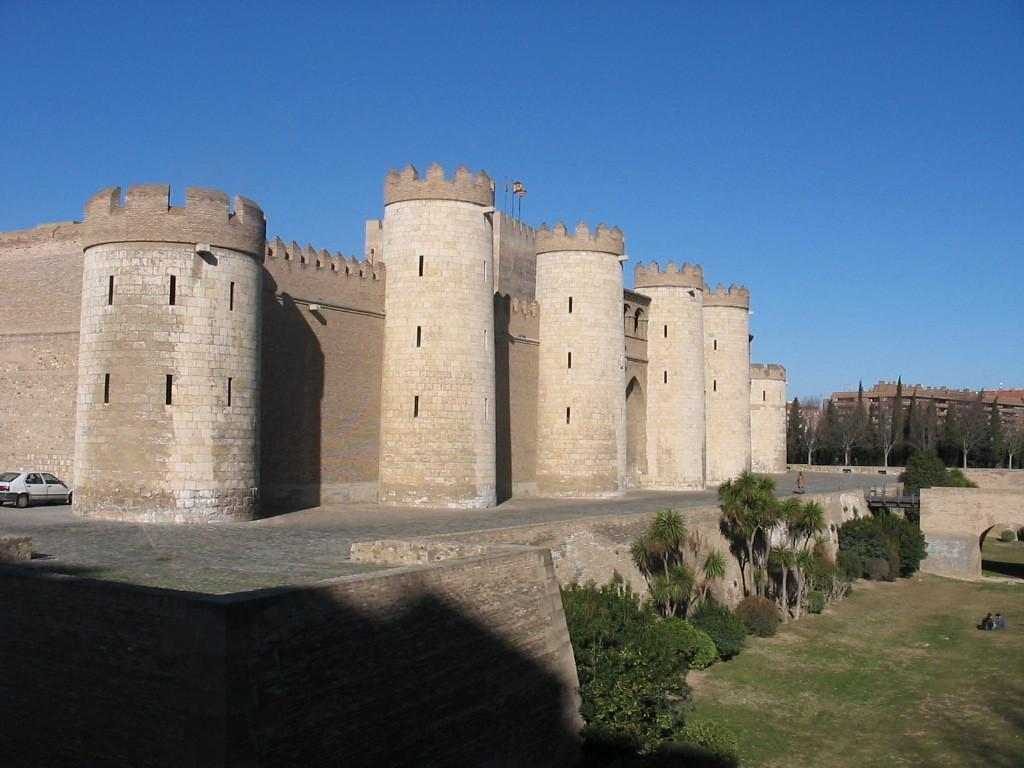What type of vegetation can be seen in the image? There are trees in the image. What color are the trees? The trees are green. What mode of transportation is present in the image? There is a vehicle in the image. What color is the vehicle? The vehicle is white. What type of structure can be seen in the image? There is a building in the image. What color is the building? The building is brown. What part of the natural environment is visible in the image? The sky is visible in the image. What color is the sky? The sky is blue. Can you tell me how many bushes are present in the image? There are no bushes mentioned in the provided facts, so it is impossible to determine their presence or quantity in the image. Is there a partner standing next to the building in the image? There is no mention of a partner or any other person in the image, so it cannot be determined if one is present. 